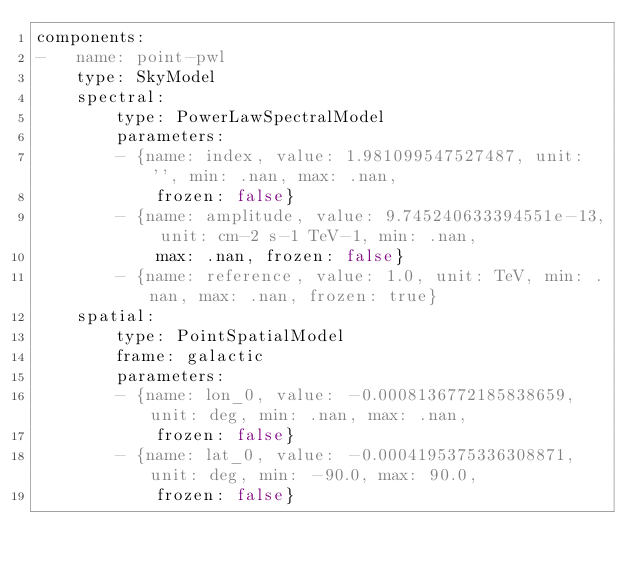Convert code to text. <code><loc_0><loc_0><loc_500><loc_500><_YAML_>components:
-   name: point-pwl
    type: SkyModel
    spectral:
        type: PowerLawSpectralModel
        parameters:
        - {name: index, value: 1.981099547527487, unit: '', min: .nan, max: .nan,
            frozen: false}
        - {name: amplitude, value: 9.745240633394551e-13, unit: cm-2 s-1 TeV-1, min: .nan,
            max: .nan, frozen: false}
        - {name: reference, value: 1.0, unit: TeV, min: .nan, max: .nan, frozen: true}
    spatial:
        type: PointSpatialModel
        frame: galactic
        parameters:
        - {name: lon_0, value: -0.0008136772185838659, unit: deg, min: .nan, max: .nan,
            frozen: false}
        - {name: lat_0, value: -0.0004195375336308871, unit: deg, min: -90.0, max: 90.0,
            frozen: false}
</code> 